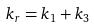<formula> <loc_0><loc_0><loc_500><loc_500>k _ { r } = k _ { 1 } + k _ { 3 }</formula> 